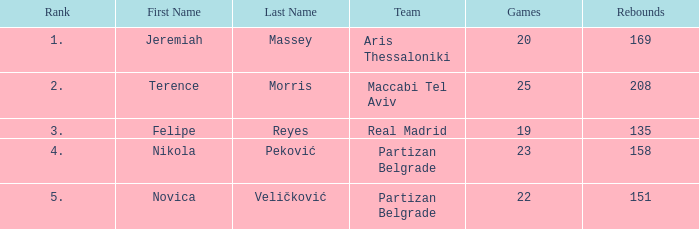What is the number of Games for the Maccabi Tel Aviv Team with less than 208 Rebounds? None. 